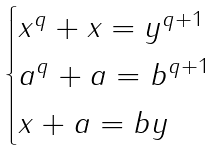Convert formula to latex. <formula><loc_0><loc_0><loc_500><loc_500>\begin{cases} x ^ { q } + x = y ^ { q + 1 } \\ a ^ { q } + a = b ^ { q + 1 } \\ x + a = b y \end{cases}</formula> 